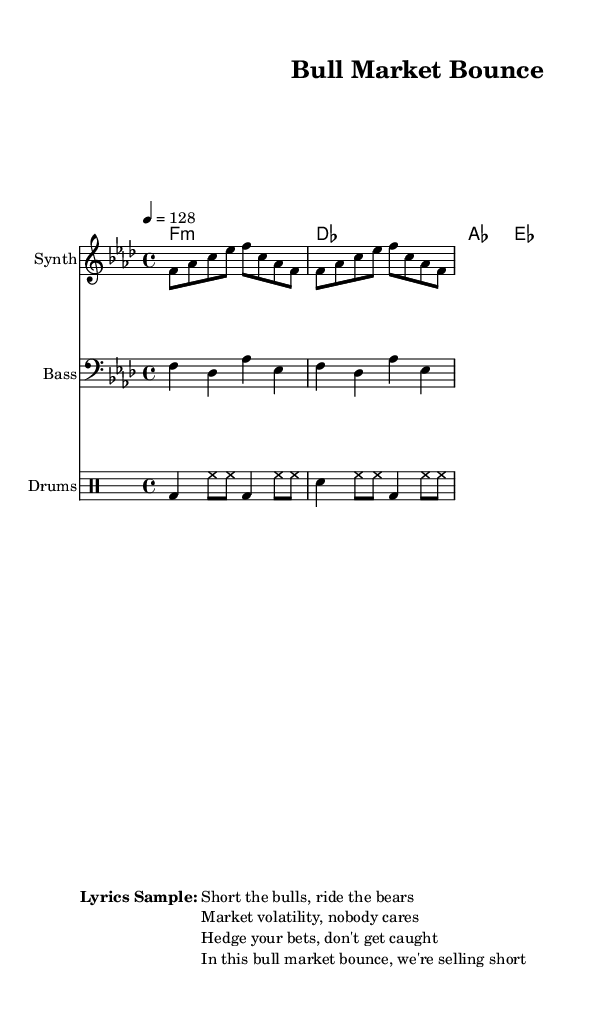What is the key signature of this music? The key signature indicates that the piece is in F minor. It is identified by the presence of four flats (B♭, E♭, A♭, D♭) in the key signature section.
Answer: F minor What is the time signature of this music? The time signature is indicated at the beginning of the score as 4/4, meaning there are four beats in each measure and the quarter note gets one beat.
Answer: 4/4 What is the tempo of this music? The tempo is marked as 4 = 128, which indicates the beats per minute, signifying a fast-paced rhythm typical in house music.
Answer: 128 How many measures are in the melody? By examining the melody line, it consists of two identical phrase structures, each comprising four beats; therefore, there are eight measures in total (two phrases, four measures each).
Answer: 8 What instruments are included in this piece? The score indicates the presence of three instruments: a Synth for the melody, a Bass for the bassline, and a Drum staff for rhythm patterns.
Answer: Synth, Bass, Drums What is the lyrical theme of this song? The lyrics provided reflect a theme centered around market dynamics, emphasizing strategies related to trading in a volatile market environment, which aligns with the song's title and motif.
Answer: Financial markets What is the primary rhythmic pattern used in the drums? The drum pattern consists of a combination of bass drums, snare hits, and closed hi-hats, arranged to create a driving rhythm typical in house music.
Answer: Bass, snare, hi-hat 